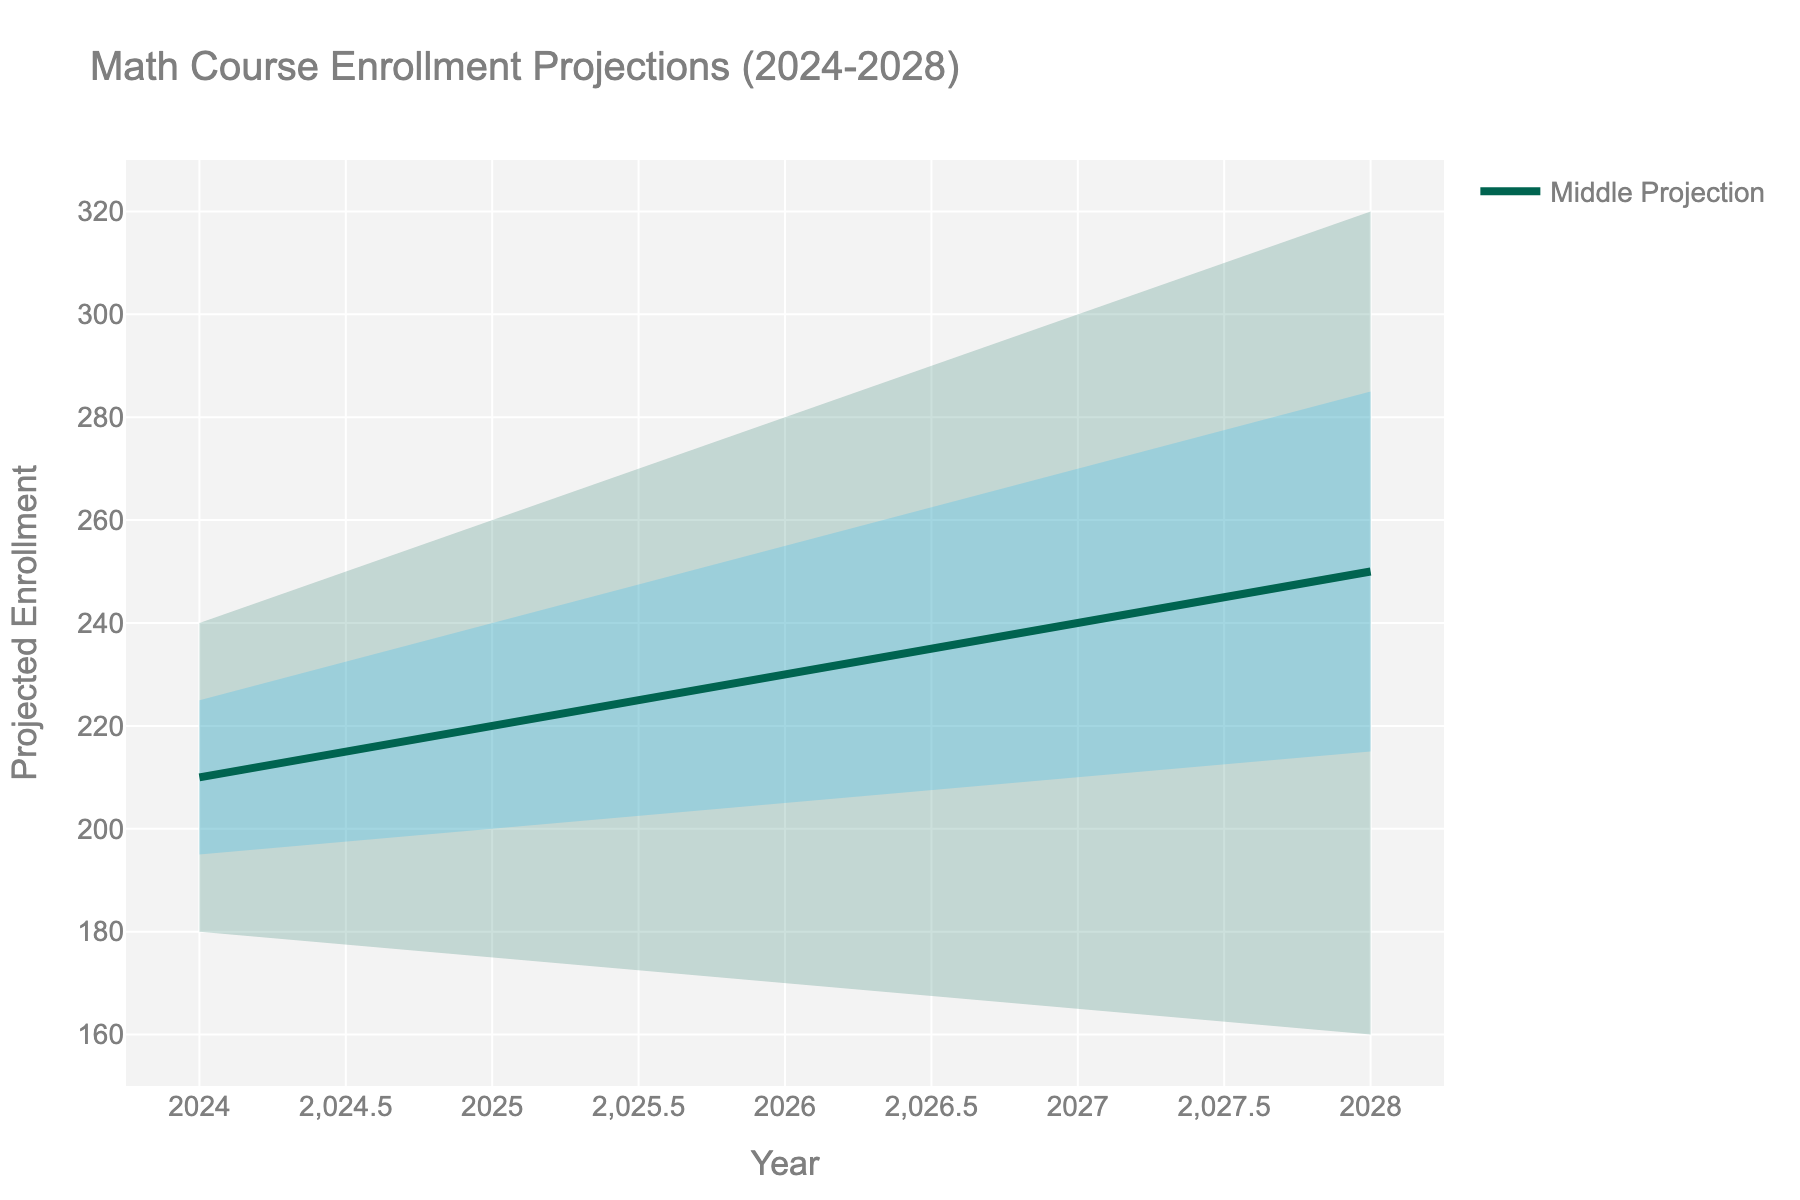what is the title of the figure? The title is located at the top-center of the figure. It provides a summary of what the visualization is about. Here, it reads: 'Math Course Enrollment Projections (2024-2028)'.
Answer: Math Course Enrollment Projections (2024-2028) What year has the highest upper bound for projected enrollment? The upper bound line can be found in the chart's shaded regions. The year with the highest point on this line represents the highest upper bound for projected enrollment, which is in 2028 at 320 students.
Answer: 2028 What is the projected middle enrollment for 2026? The projected middle enrollment is marked by the middle line, which is also labeled as 'Middle Projection'. Follow this line to the year 2026, where the value is 230 students.
Answer: 230 Which year shows the steepest increase in upper bound from the previous year? By looking at the topmost shaded area, find the year-to-year differences. The steepest increase appears between 2027 and 2028, where the upper bound rises from 300 to 320, an increase of 20 students.
Answer: 2027 to 2028 What is the difference in the middle projection between 2024 and 2028? The middle projection lines for 2024 and 2028 show values of 210 and 250 respectively. The difference is calculated as 250 - 210 = 40.
Answer: 40 Which year has the smallest range between the upper and lower bounds? Measure the distance between the lower and upper bounds for each year. 2024 has the smallest range, with a difference of 240 - 180 = 60 students.
Answer: 2024 What is the average upper middle value over the projected years? Sum all the upper middle values (225 + 240 + 255 + 270 + 285 = 1275) and divide by the number of years (5), yielding 1275 / 5 = 255.
Answer: 255 In what way does the confidence in enrollment projections change over time? The range between the lower bound and upper bound increases as the years progress from 2024 to 2028, indicating greater uncertainty in the projections the further into the future they go.
Answer: Increases What is the projected lower middle enrollment for 2027? Follow the lower middle line to the year 2027, where the value is 210 students.
Answer: 210 